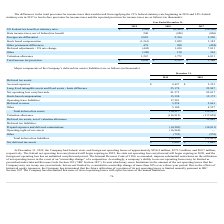According to Cornerstone Ondemand's financial document, What was the company's federal net operating losses in 2019? According to the financial document, $256.8 million. The relevant text states: "and foreign net operating losses of approximately $256.8 million, $275.5 million, and $89.7 million,..." Also, What was the company's state net operating losses in 2019? According to the financial document, $275.5 million. The relevant text states: "operating losses of approximately $256.8 million, $275.5 million, and $89.7 million,..." Also, What was the Deferred tax assets, net of valuation allowance in 2019? According to the financial document, 33,302 (in thousands). The relevant text states: "Deferred tax assets, net of valuation allowance 33,302 12,849..." Also, can you calculate: What is the percentage change in Stock-based compensation between 2018 and 2019? To answer this question, I need to perform calculations using the financial data. The calculation is: (15,398-15,172)/15,172, which equals 1.49 (percentage). This is based on the information: "Stock-based compensation 15,398 15,172 Stock-based compensation 15,398 15,172..." The key data points involved are: 15,172, 15,398. Also, can you calculate: What is the percentage change in Deferred revenue between 2018 and 2019? To answer this question, I need to perform calculations using the financial data. The calculation is: (3,258-2,861)/2,861, which equals 13.88 (percentage). This is based on the information: "Deferred revenue 3,258 2,861 Deferred revenue 3,258 2,861..." The key data points involved are: 2,861, 3,258. Also, can you calculate: What percentage of total deferred tax assets consist of accrued expenses in 2018? Based on the calculation: (2,353/129,907), the result is 1.81 (percentage). This is based on the information: "Total deferred tax assets 150,217 129,907 Accrued expenses $ 2,427 $ 2,353..." The key data points involved are: 129,907, 2,353. 